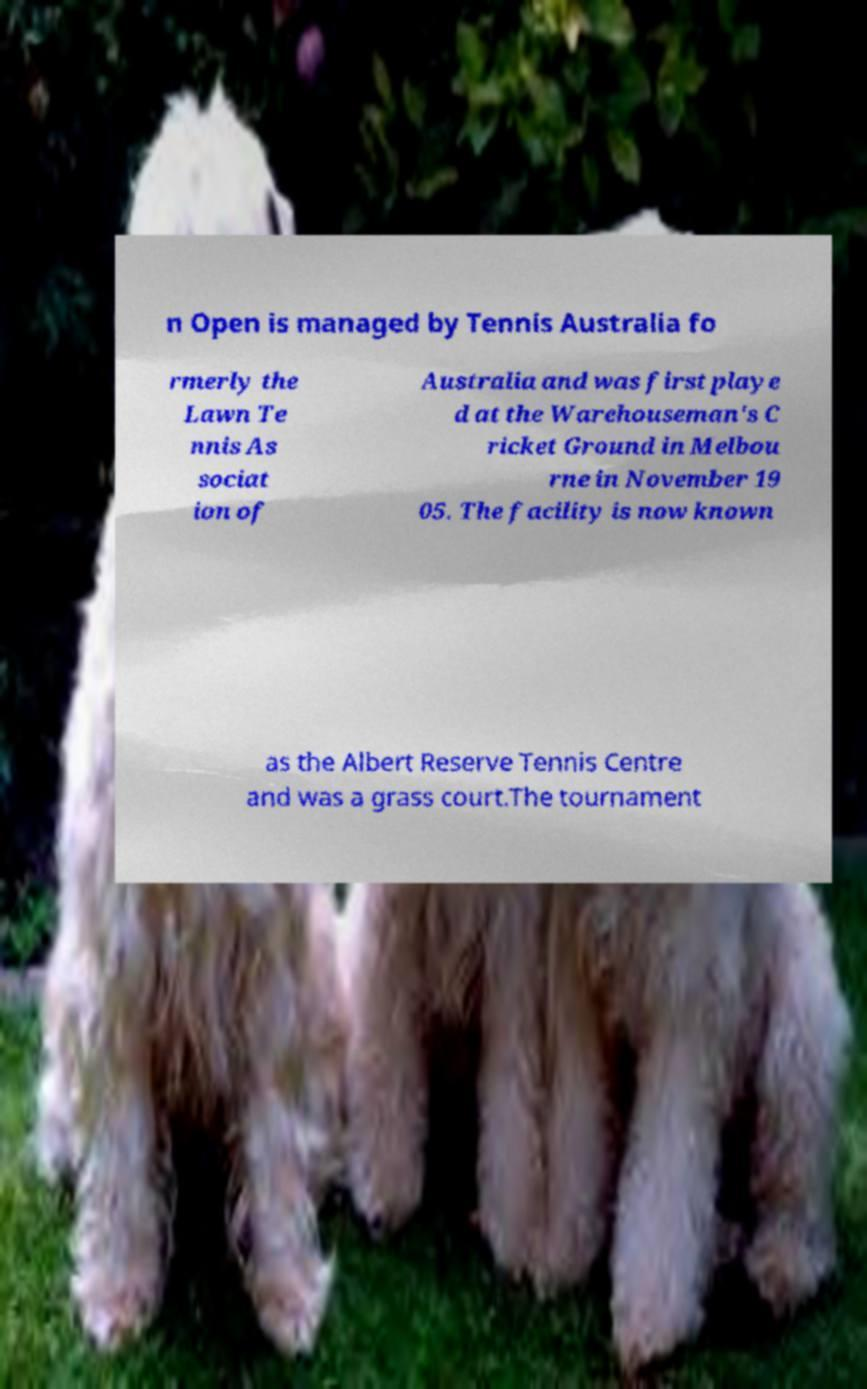Could you extract and type out the text from this image? n Open is managed by Tennis Australia fo rmerly the Lawn Te nnis As sociat ion of Australia and was first playe d at the Warehouseman's C ricket Ground in Melbou rne in November 19 05. The facility is now known as the Albert Reserve Tennis Centre and was a grass court.The tournament 